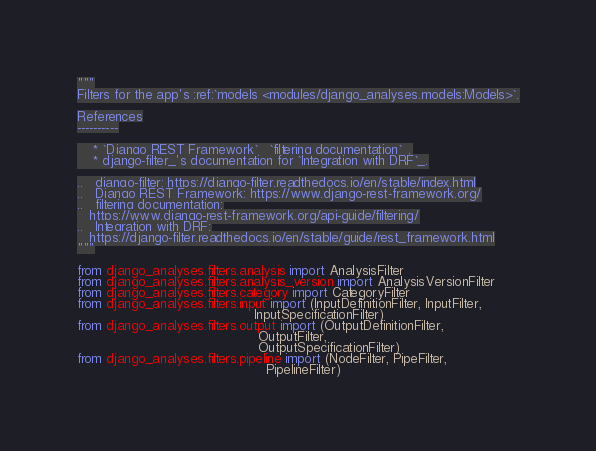<code> <loc_0><loc_0><loc_500><loc_500><_Python_>"""
Filters for the app's :ref:`models <modules/django_analyses.models:Models>`.

References
----------

    * `Django REST Framework`_ `filtering documentation`_.
    * django-filter_'s documentation for `Integration with DRF`_.

.. _django-filter: https://django-filter.readthedocs.io/en/stable/index.html
.. _Django REST Framework: https://www.django-rest-framework.org/
.. _filtering documentation:
   https://www.django-rest-framework.org/api-guide/filtering/
.. _Integration with DRF:
   https://django-filter.readthedocs.io/en/stable/guide/rest_framework.html
"""

from django_analyses.filters.analysis import AnalysisFilter
from django_analyses.filters.analysis_version import AnalysisVersionFilter
from django_analyses.filters.category import CategoryFilter
from django_analyses.filters.input import (InputDefinitionFilter, InputFilter,
                                           InputSpecificationFilter)
from django_analyses.filters.output import (OutputDefinitionFilter,
                                            OutputFilter,
                                            OutputSpecificationFilter)
from django_analyses.filters.pipeline import (NodeFilter, PipeFilter,
                                              PipelineFilter)
</code> 